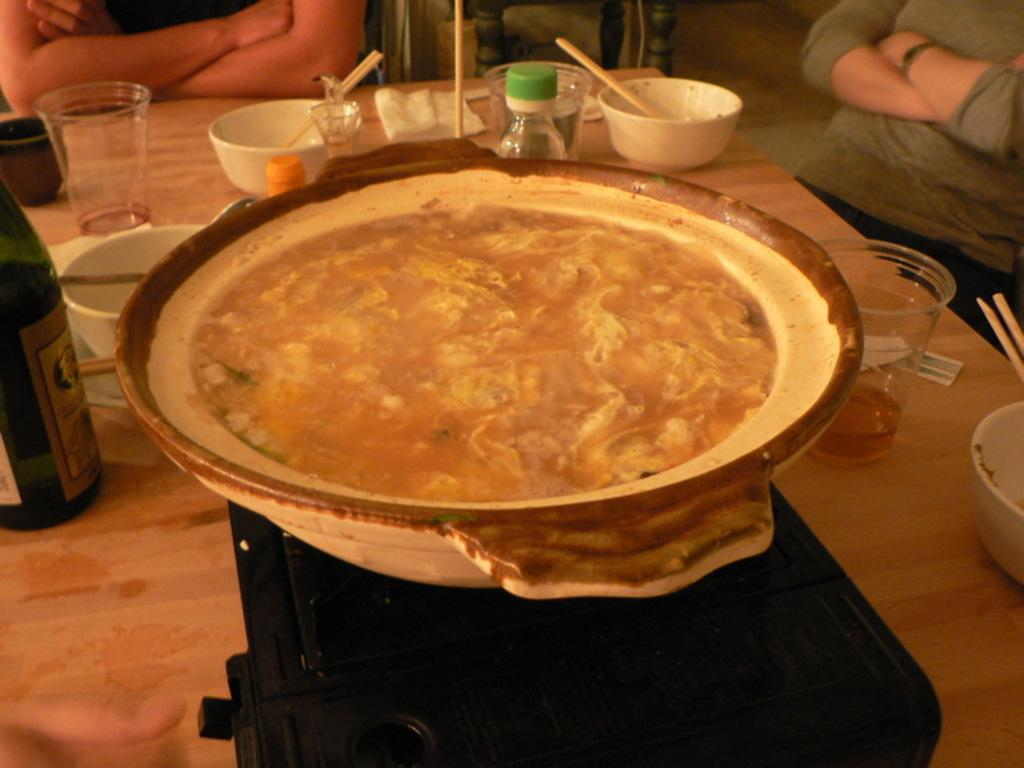What types of containers are on the table in the image? There are glasses, cups, and bottles on the table. What utensils are on the table? Chopsticks are on the table. What can be used for cleaning or wiping in the image? Tissue papers are on the table. What is in a bowl on the table? There is food in a bowl on the table. What type of alcoholic beverage is present in the image? There is a wine bottle on the table. How many people are beside the table in the image? There are two persons beside the table. What type of tree is growing in the middle of the table? There is no tree growing in the middle of the table in the image. What caption is written on the tissue paper? There is no caption written on the tissue paper in the image; it is a plain tissue paper. 